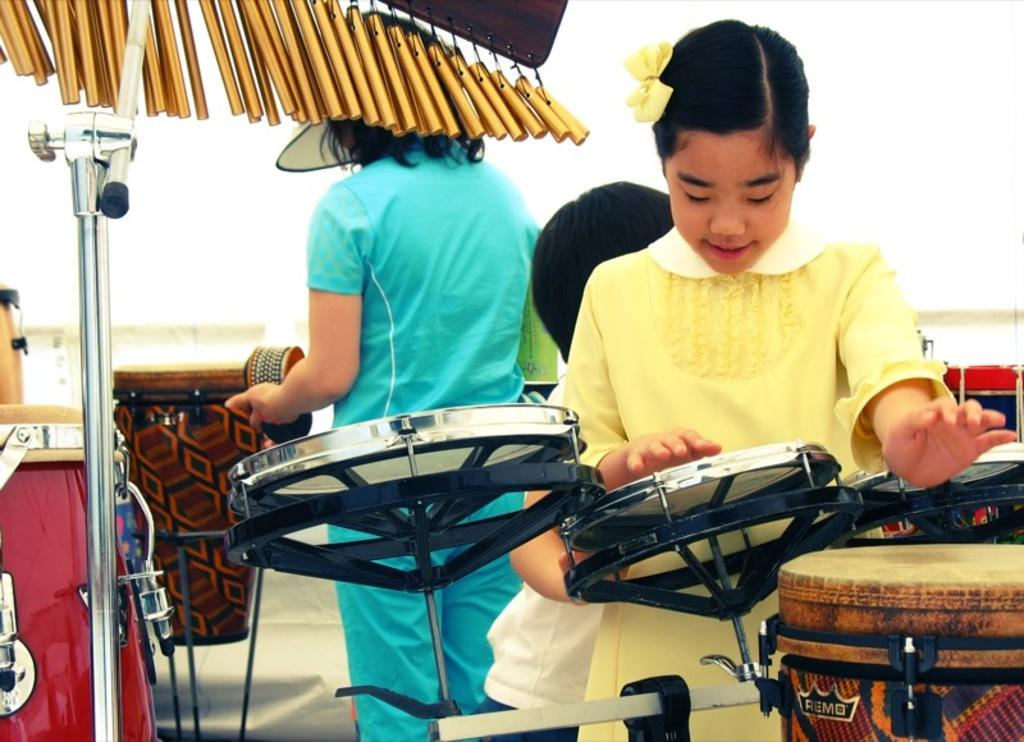Who is the main subject in the image? There is a girl in the image. What is the girl wearing? The girl is wearing a yellow dress. What is the girl doing in the image? The girl is playing the drum. Are there any other people in the image? Yes, there are other girls in the image. What are the other girls doing? The other girls are doing some activity. Where is the cord for the drum located in the image? There is no cord for the drum visible in the image. What type of market is shown in the image? There is no market present in the image. 